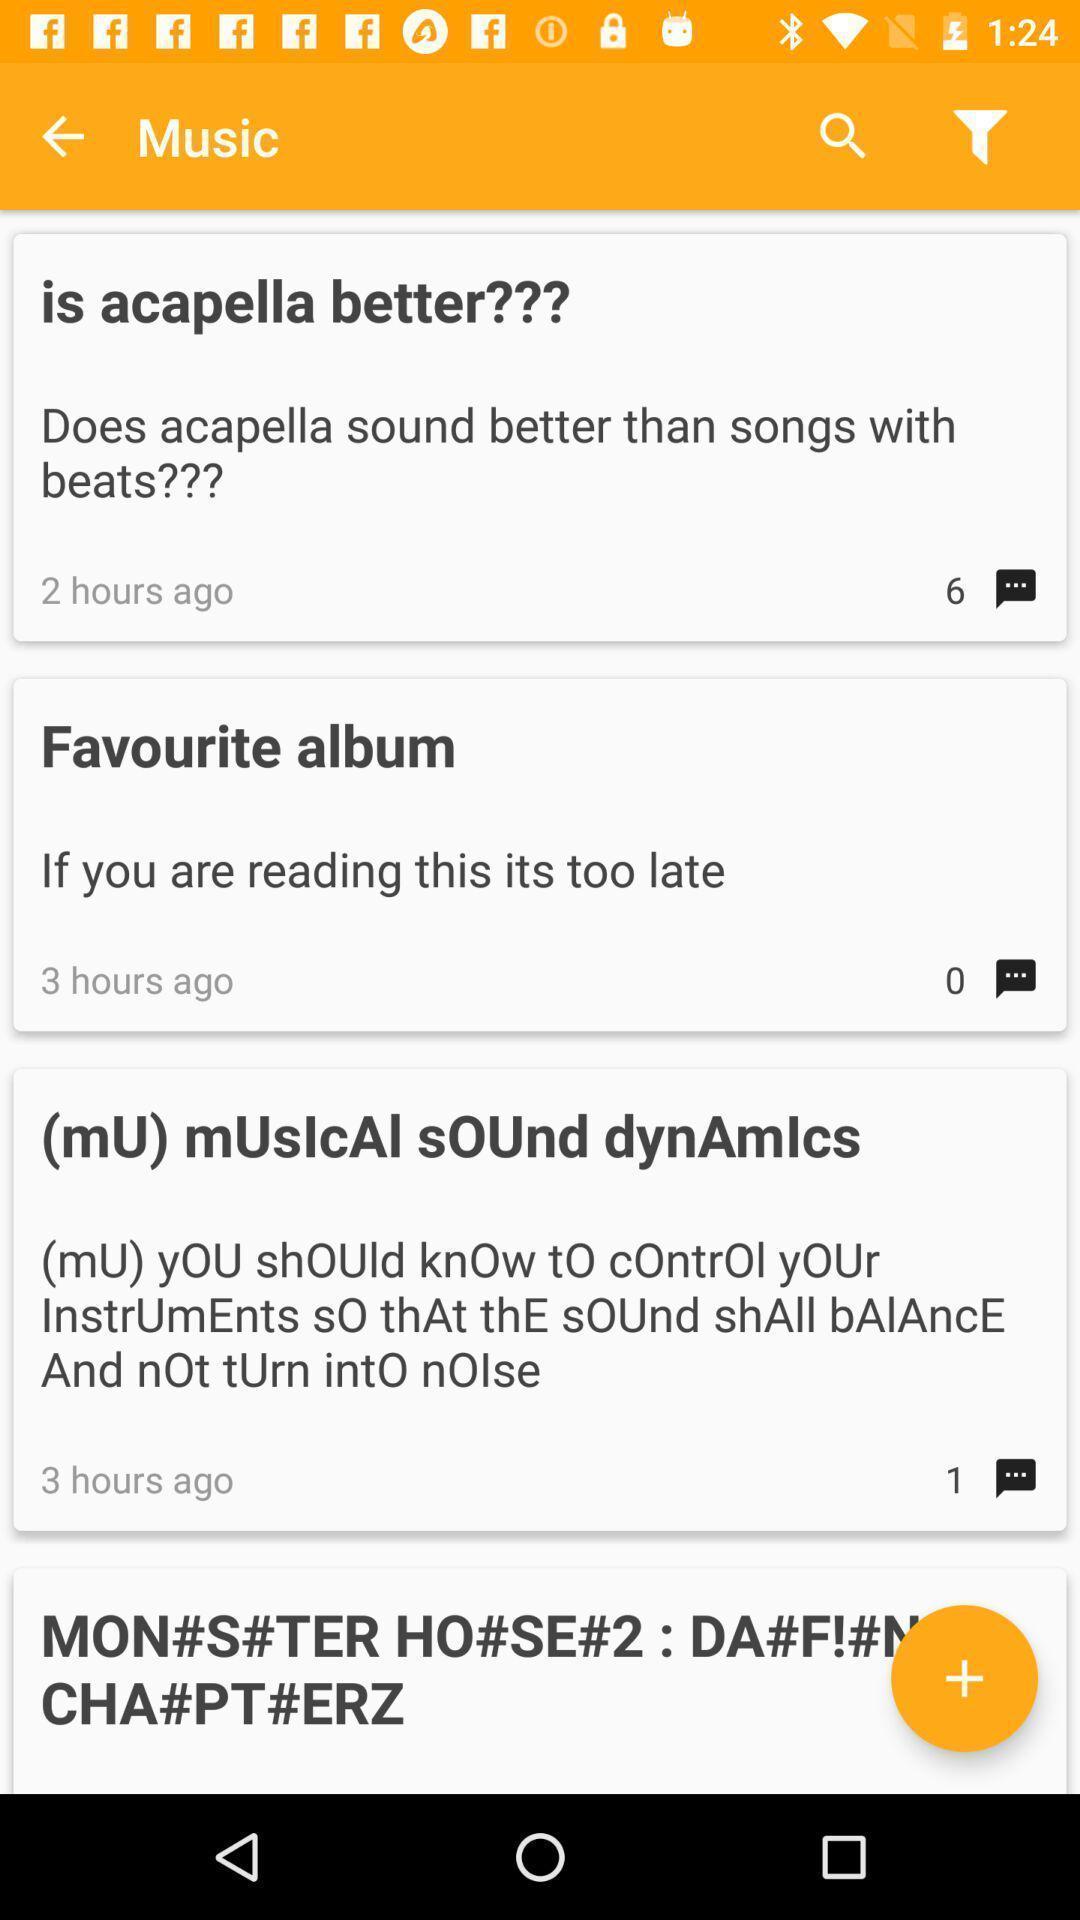What is the overall content of this screenshot? Page displaying number of music options in a music app. 